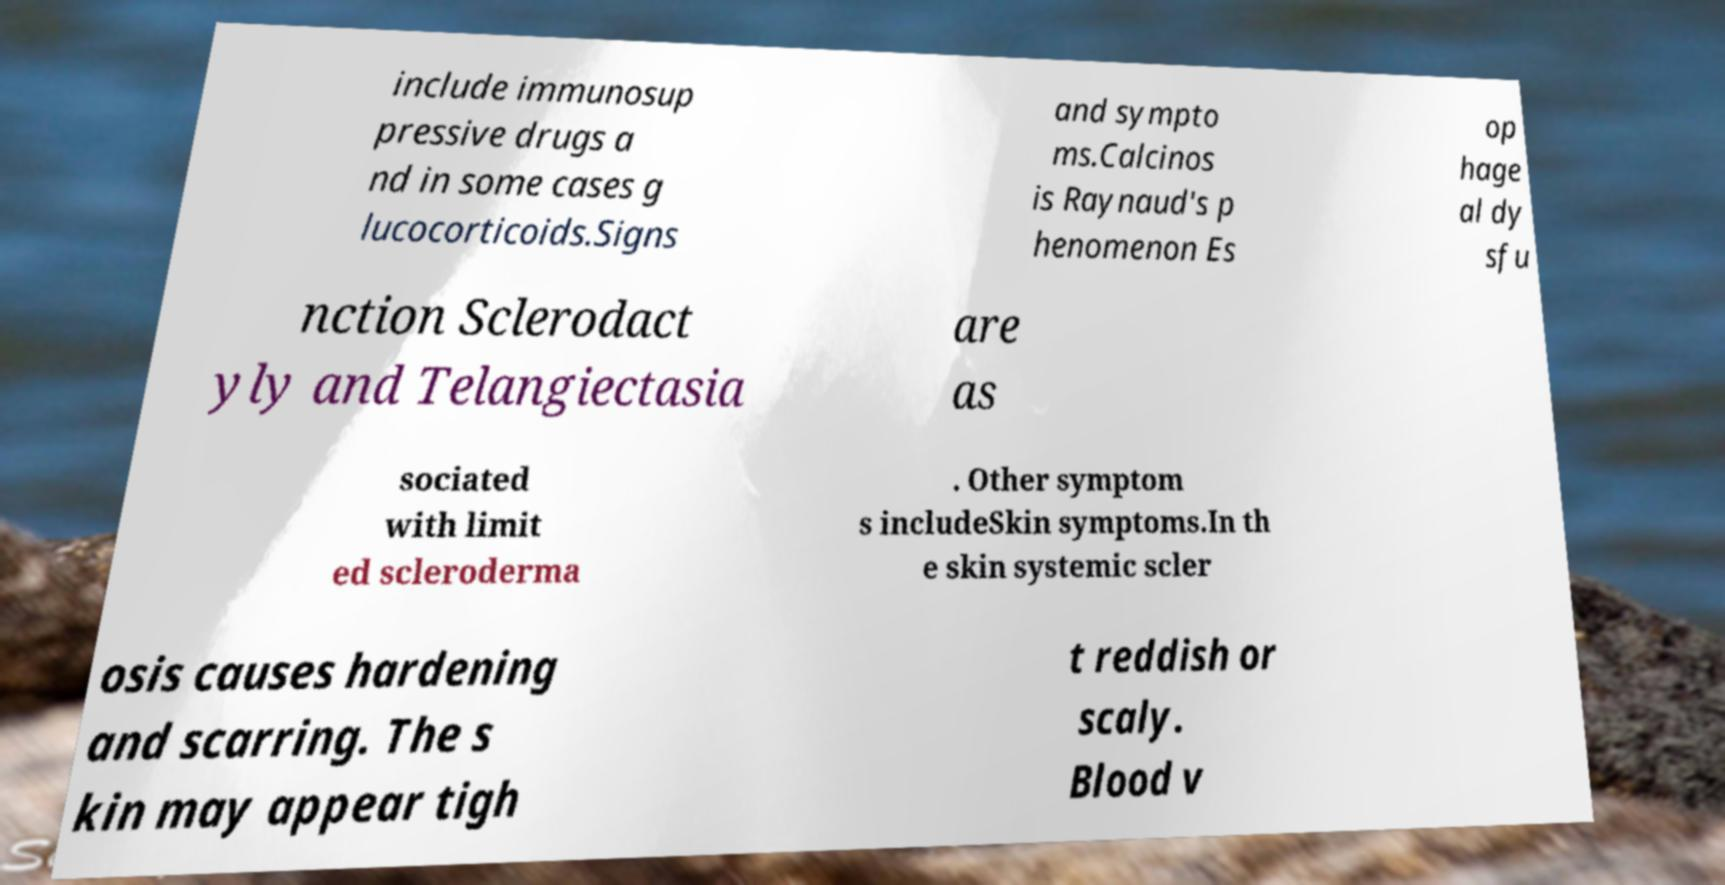I need the written content from this picture converted into text. Can you do that? include immunosup pressive drugs a nd in some cases g lucocorticoids.Signs and sympto ms.Calcinos is Raynaud's p henomenon Es op hage al dy sfu nction Sclerodact yly and Telangiectasia are as sociated with limit ed scleroderma . Other symptom s includeSkin symptoms.In th e skin systemic scler osis causes hardening and scarring. The s kin may appear tigh t reddish or scaly. Blood v 